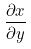Convert formula to latex. <formula><loc_0><loc_0><loc_500><loc_500>\frac { \partial x } { \partial y }</formula> 